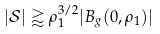<formula> <loc_0><loc_0><loc_500><loc_500>| \mathcal { S } | \gtrapprox \rho _ { 1 } ^ { 3 / 2 } | B _ { g } ( 0 , \rho _ { 1 } ) |</formula> 